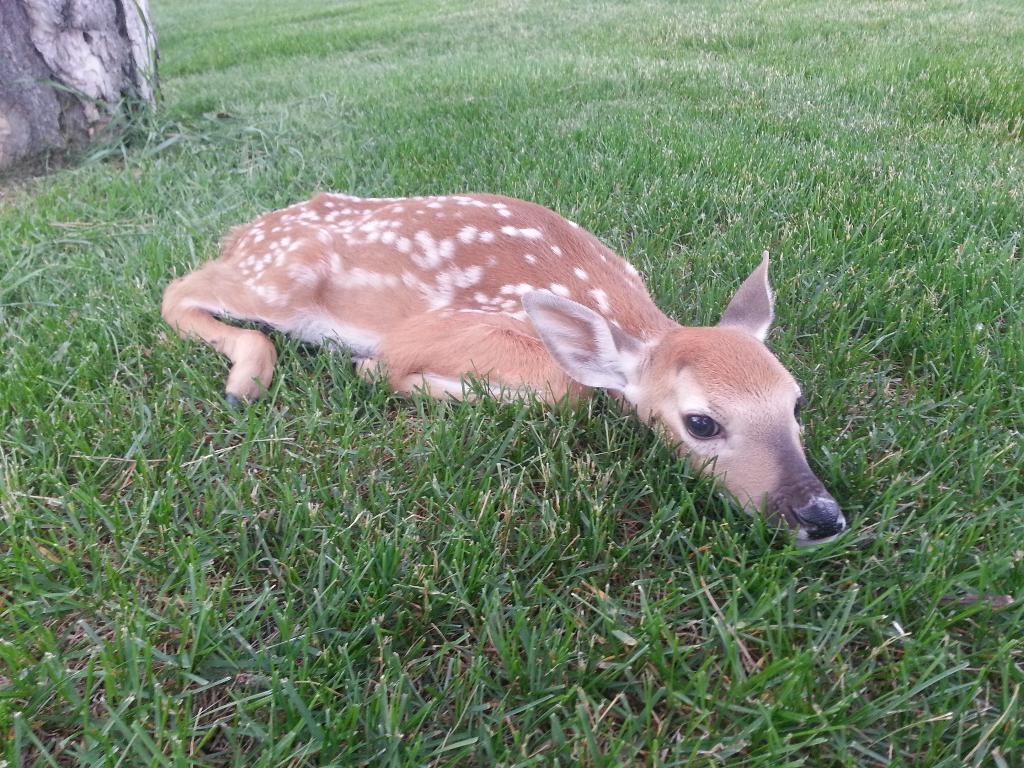Could you give a brief overview of what you see in this image? In this image, I can see a deer lying on the grass. This looks like a tree trunk. 